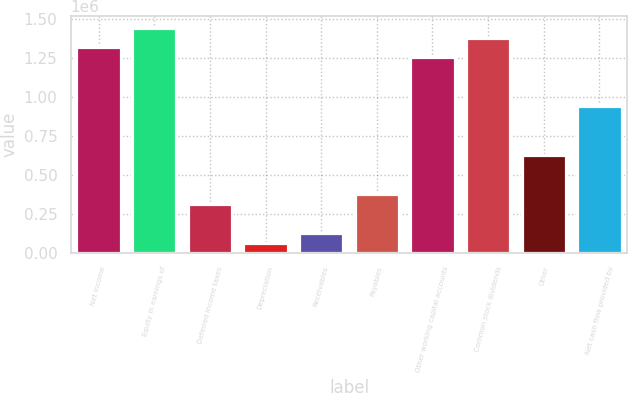<chart> <loc_0><loc_0><loc_500><loc_500><bar_chart><fcel>Net income<fcel>Equity in earnings of<fcel>Deferred income taxes<fcel>Depreciation<fcel>Receivables<fcel>Payables<fcel>Other working capital accounts<fcel>Common stock dividends<fcel>Other<fcel>Net cash flow provided by<nl><fcel>1.32083e+06<fcel>1.44655e+06<fcel>315068<fcel>63627.9<fcel>126488<fcel>377927<fcel>1.25797e+06<fcel>1.38369e+06<fcel>629367<fcel>943666<nl></chart> 